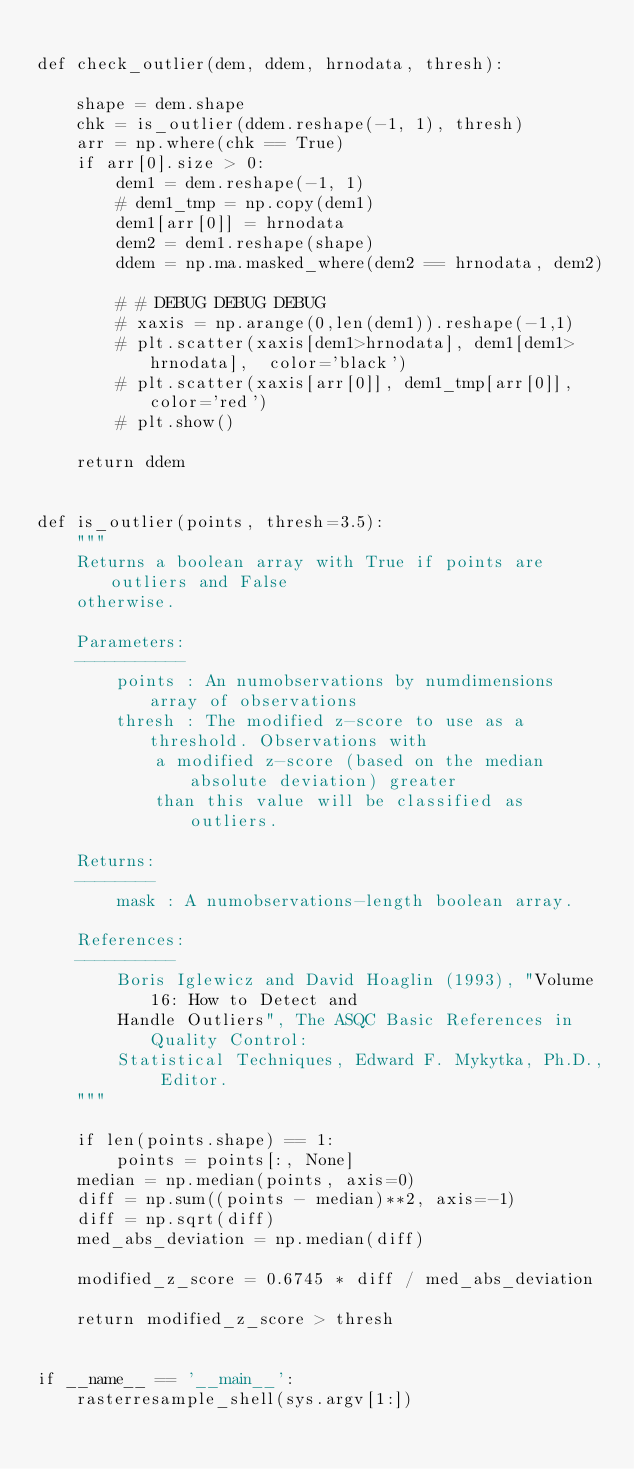Convert code to text. <code><loc_0><loc_0><loc_500><loc_500><_Python_>
def check_outlier(dem, ddem, hrnodata, thresh):

    shape = dem.shape
    chk = is_outlier(ddem.reshape(-1, 1), thresh)
    arr = np.where(chk == True)
    if arr[0].size > 0:
        dem1 = dem.reshape(-1, 1)
        # dem1_tmp = np.copy(dem1)
        dem1[arr[0]] = hrnodata
        dem2 = dem1.reshape(shape)
        ddem = np.ma.masked_where(dem2 == hrnodata, dem2)

        # # DEBUG DEBUG DEBUG
        # xaxis = np.arange(0,len(dem1)).reshape(-1,1)
        # plt.scatter(xaxis[dem1>hrnodata], dem1[dem1>hrnodata],  color='black')
        # plt.scatter(xaxis[arr[0]], dem1_tmp[arr[0]], color='red')
        # plt.show()

    return ddem


def is_outlier(points, thresh=3.5):
    """
    Returns a boolean array with True if points are outliers and False 
    otherwise.

    Parameters:
    -----------
        points : An numobservations by numdimensions array of observations
        thresh : The modified z-score to use as a threshold. Observations with
            a modified z-score (based on the median absolute deviation) greater
            than this value will be classified as outliers.

    Returns:
    --------
        mask : A numobservations-length boolean array.

    References:
    ----------
        Boris Iglewicz and David Hoaglin (1993), "Volume 16: How to Detect and
        Handle Outliers", The ASQC Basic References in Quality Control:
        Statistical Techniques, Edward F. Mykytka, Ph.D., Editor. 
    """

    if len(points.shape) == 1:
        points = points[:, None]
    median = np.median(points, axis=0)
    diff = np.sum((points - median)**2, axis=-1)
    diff = np.sqrt(diff)
    med_abs_deviation = np.median(diff)

    modified_z_score = 0.6745 * diff / med_abs_deviation

    return modified_z_score > thresh


if __name__ == '__main__':
    rasterresample_shell(sys.argv[1:])
</code> 